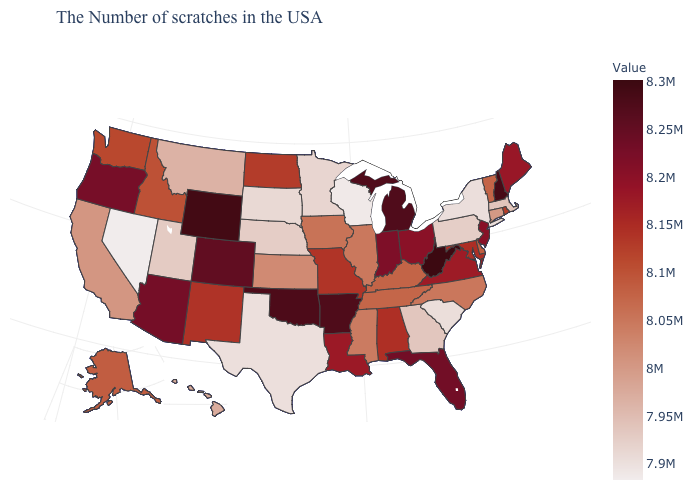Is the legend a continuous bar?
Concise answer only. Yes. Among the states that border Utah , which have the lowest value?
Quick response, please. Nevada. Does New Hampshire have a lower value than New Jersey?
Write a very short answer. No. Is the legend a continuous bar?
Give a very brief answer. Yes. Which states have the highest value in the USA?
Write a very short answer. West Virginia. 